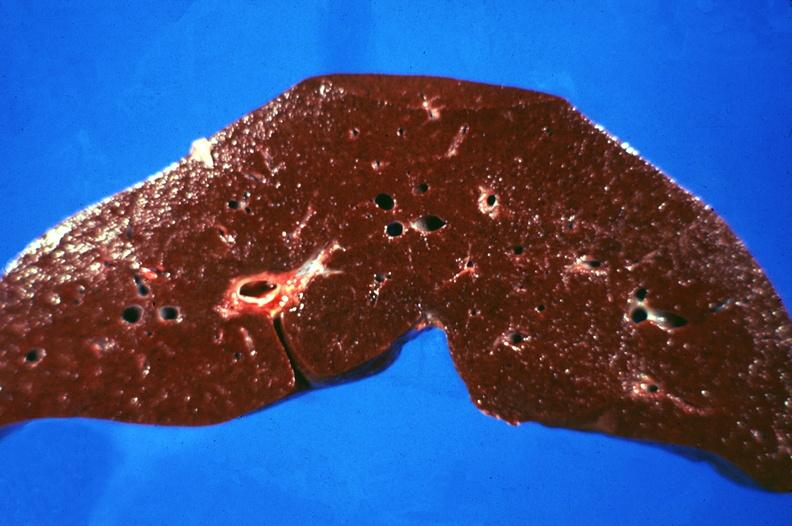what is present?
Answer the question using a single word or phrase. Hepatobiliary 